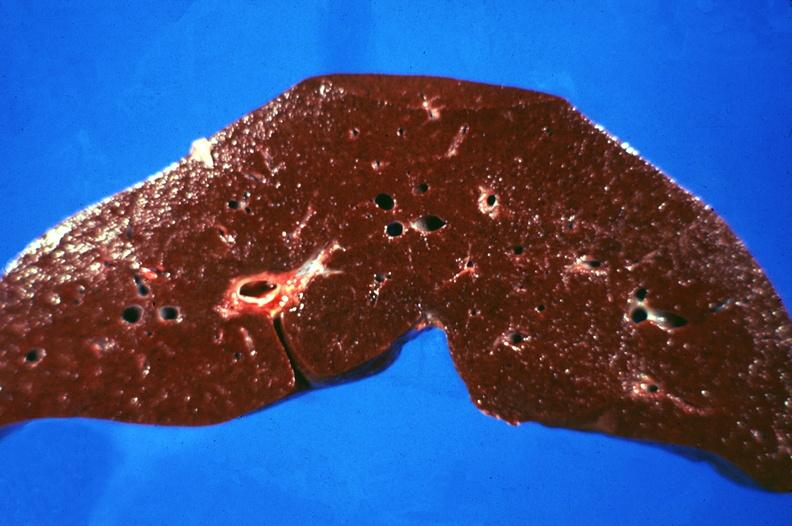what is present?
Answer the question using a single word or phrase. Hepatobiliary 